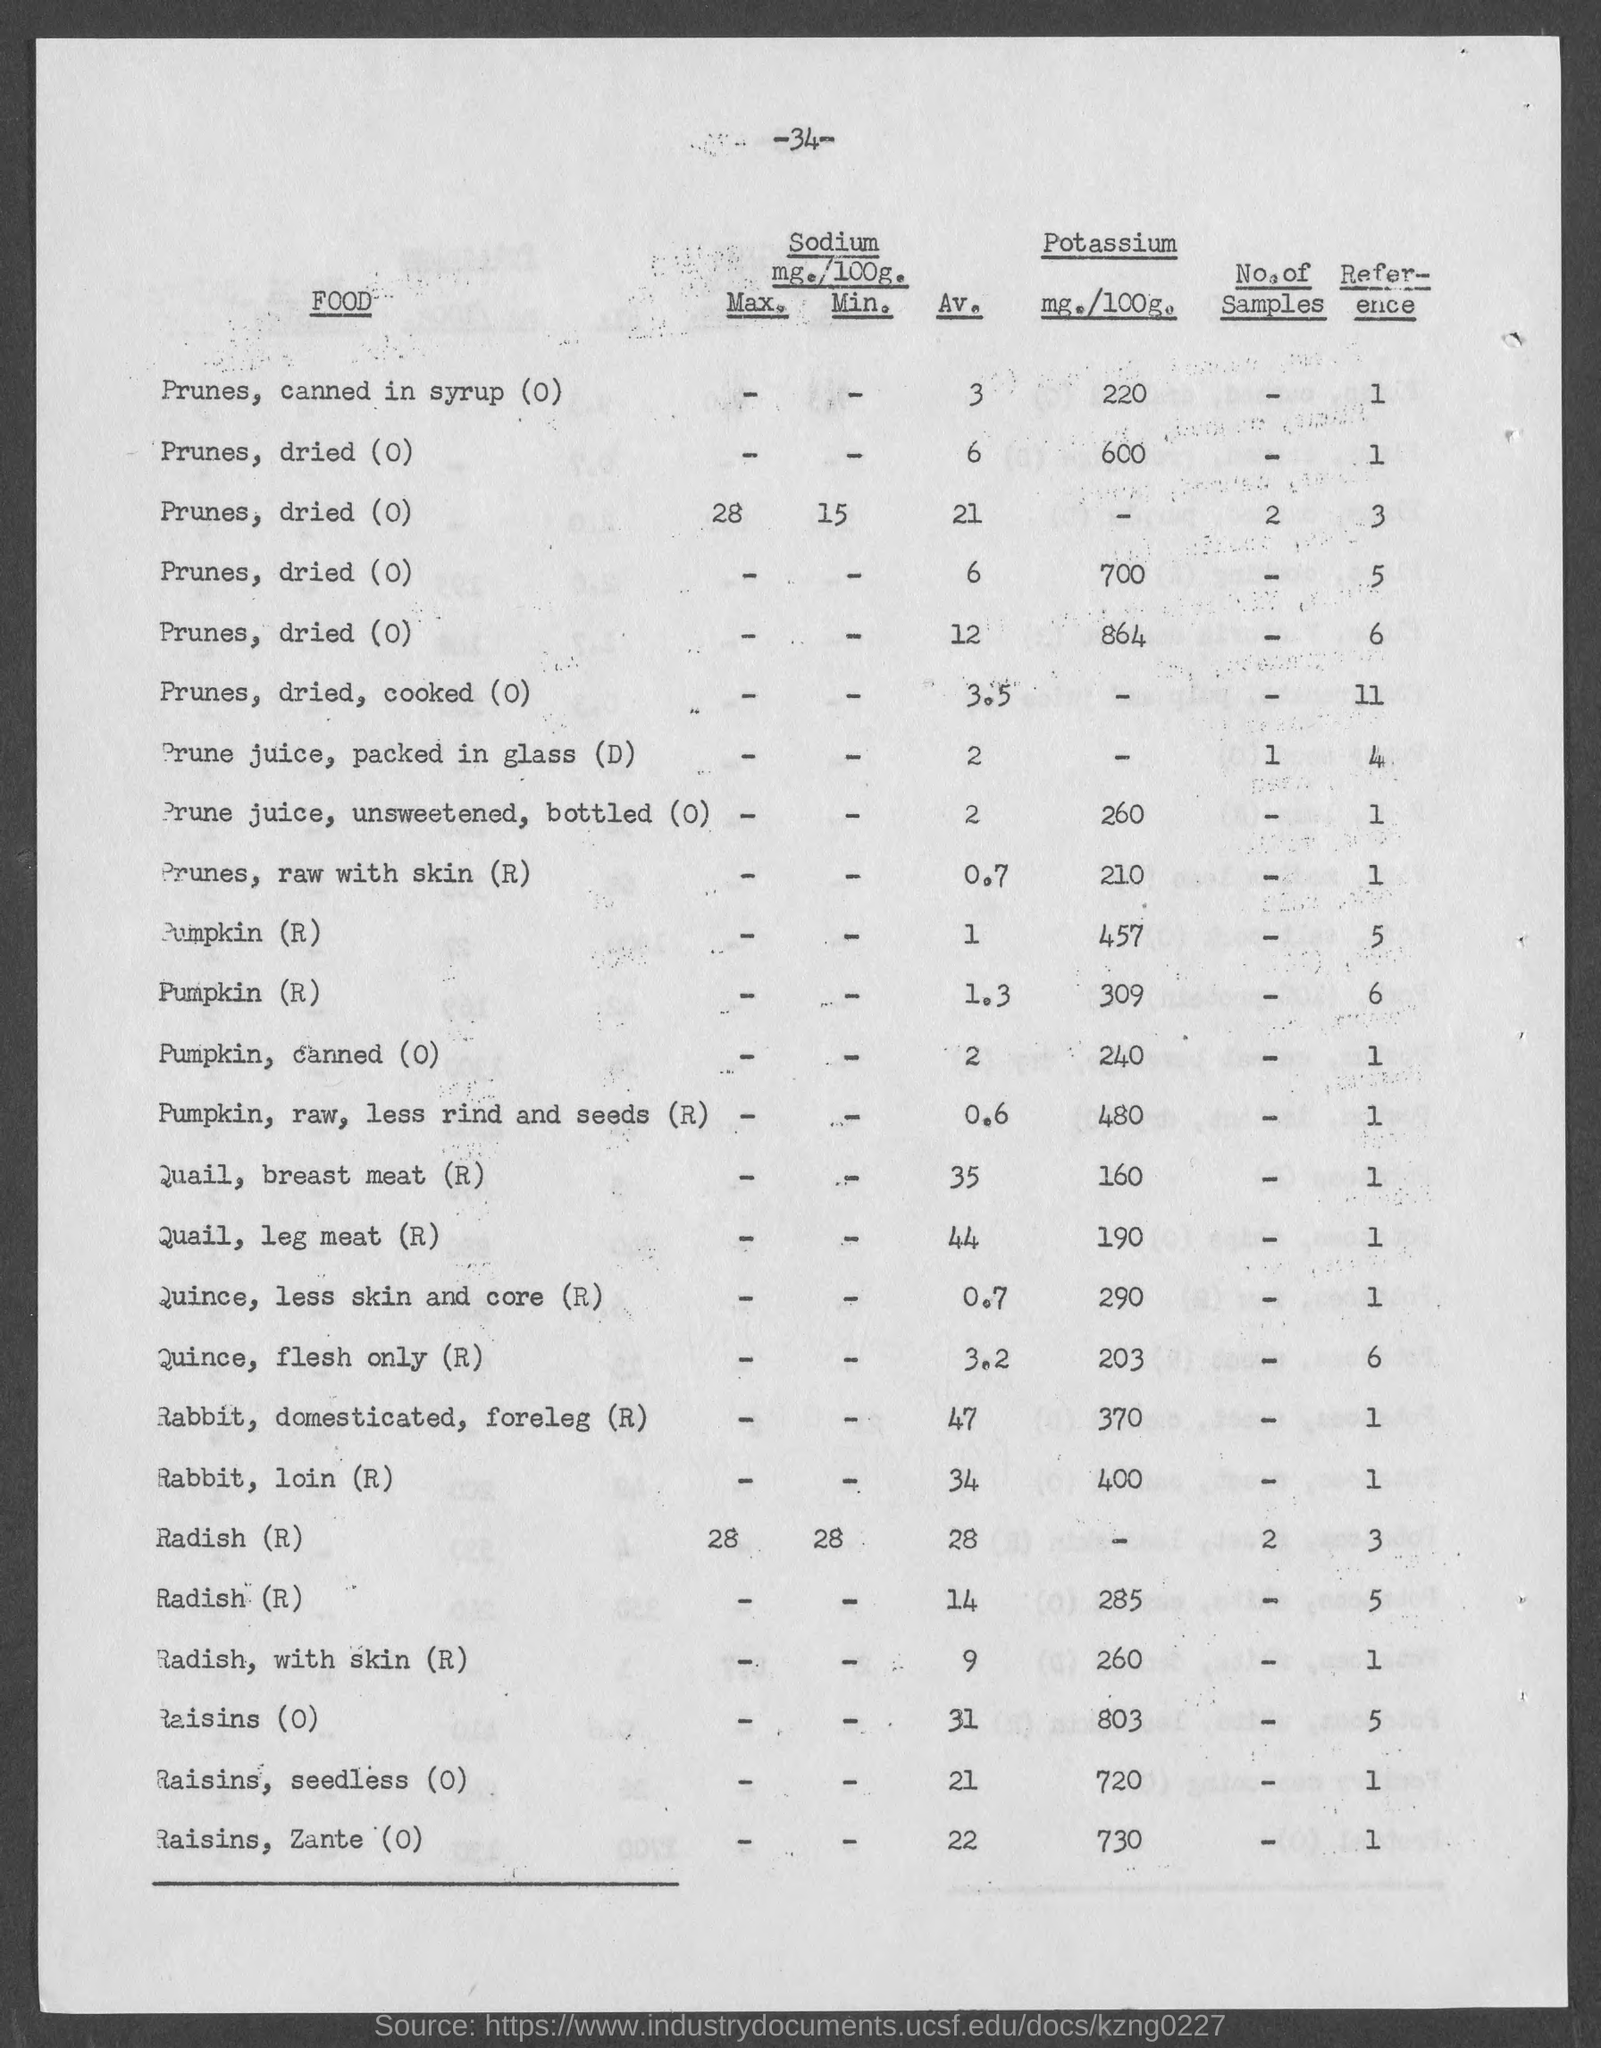Outline some significant characteristics in this image. The average value of rabbit loin, as mentioned on the given page, is 34. The amount of potassium present in raw pumpkin, without the rind and seeds, is 480 milligrams per 100 grams, as indicated on the given page. The amount of potassium present in canned prunes, as mentioned on the given page, is 220. The quail breast meat (R) contains a significant amount of potassium, with the specific value listed as 160. The amount of potassium present in unsweetened, bottled prune juice is 260 milligrams per 100 milliliters, as stated on the given page. 